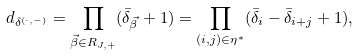Convert formula to latex. <formula><loc_0><loc_0><loc_500><loc_500>d _ { \delta ^ { ( \cdot , - ) } } = \prod _ { \vec { \beta } \in R _ { J , + } } ( \bar { \delta } _ { \vec { \beta } } + 1 ) = \prod _ { ( i , j ) \in \eta ^ { * } } ( \bar { \delta } _ { i } - \bar { \delta } _ { i + j } + 1 ) ,</formula> 